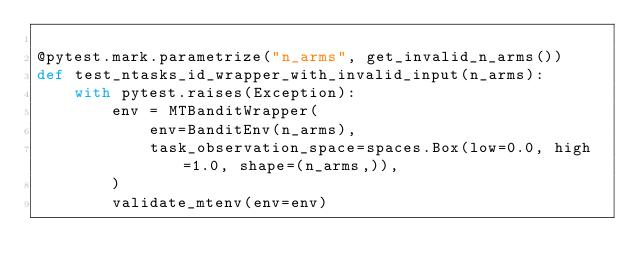Convert code to text. <code><loc_0><loc_0><loc_500><loc_500><_Python_>
@pytest.mark.parametrize("n_arms", get_invalid_n_arms())
def test_ntasks_id_wrapper_with_invalid_input(n_arms):
    with pytest.raises(Exception):
        env = MTBanditWrapper(
            env=BanditEnv(n_arms),
            task_observation_space=spaces.Box(low=0.0, high=1.0, shape=(n_arms,)),
        )
        validate_mtenv(env=env)
</code> 